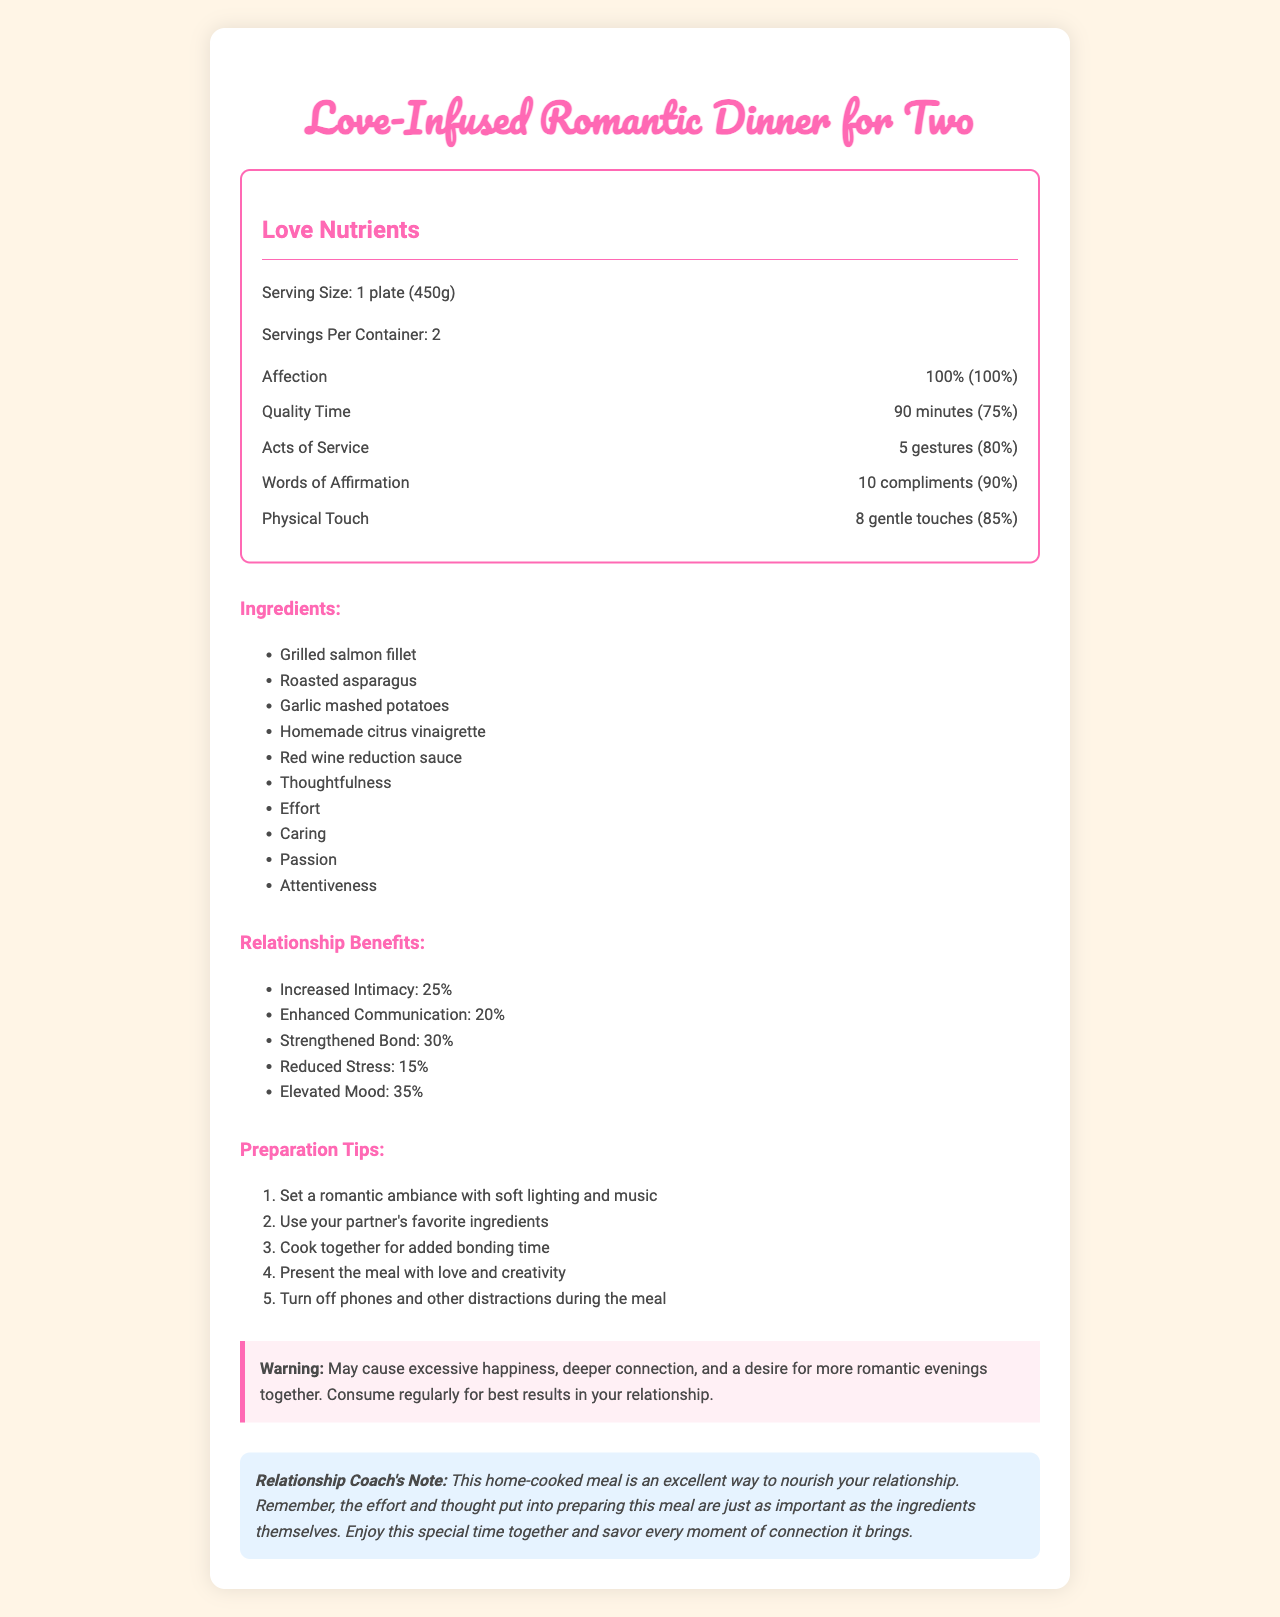what is the serving size for the meal? The document states that the serving size is "1 plate (450g)".
Answer: 1 plate (450g) how many gestures of Acts of Service are included in the meal? The "Acts of Service" nutrient lists "5 gestures" as the amount.
Answer: 5 gestures what is the daily value percentage of Words of Affirmation? The daily value percentage for "Words of Affirmation" is listed as 90% in the "Love Nutrients" section.
Answer: 90% list three ingredients used in the meal. The ingredients listed in the document include grilled salmon fillet, roasted asparagus, garlic mashed potatoes, among others.
Answer: Grilled salmon fillet, roasted asparagus, garlic mashed potatoes what is the relationship benefit with the highest percentage increase? Elevated Mood has a 35% increase, which is the highest listed.
Answer: Elevated Mood which preparation tip emphasizes reducing distractions? One of the preparation tips advises to "Turn off phones and other distractions during the meal."
Answer: Turn off phones and other distractions during the meal what is a potential side effect of consuming this meal regularly? The warning box mentions these side effects.
Answer: Excessive happiness, deeper connection, and a desire for more romantic evenings together how many servings per container are there? A. 1 B. 2 C. 3 D. 4 The document mentions that there are "2" servings per container.
Answer: B. 2 what is the amount of Quality Time in one serving? A. 60 minutes B. 75 minutes C. 90 minutes D. 120 minutes The amount of Quality Time is listed as "90 minutes" in the "Love Nutrients" section.
Answer: C. 90 minutes is there a mention of "effort" as an ingredient? Yes/No "Effort" is listed as one of the ingredients in the meal.
Answer: Yes summarize the entire document. The document uses a whimsical approach to illustrate how a romantic dinner can enhance a relationship. It includes detailed "nutrients", ingredients, relationship benefits, preparation tips, a warning, and a coach's note to underline the impact of thoughtful gestures on a partnership.
Answer: The document is a playful representation of a Nutrition Facts label for a "Love-Infused Romantic Dinner for Two." It highlights "Love Nutrients" such as Affection, Quality Time, Acts of Service, Words of Affirmation, and Physical Touch with respective amounts and daily values. The ingredients include a variety of food items and abstract elements like Thoughtfulness and Caring. It outlines relationship benefits, preparation tips, provides a warning about excessive happiness, and includes a note from a relationship coach emphasizing the importance of effort and thoughtfulness. what is the exact recipe for the garlic mashed potatoes? The document lists "garlic mashed potatoes" as an ingredient but does not provide the recipe or preparation steps.
Answer: Cannot be determined of the love nutrients listed, which one has the highest daily value percentage? The document shows that Affection has a daily value of 100%, which is the highest.
Answer: Affection explain how the document encourages partners to enhance their relationship through cooking. The document uses a mock nutrition label format to frame relationship-building activities in an enjoyable way. The inclusion of "love nutrients" and relationship benefits aligns the act of cooking and sharing a meal with nurturing and enhancing a romantic partnership.
Answer: The document encourages partners to enhance their relationship by providing a fun and engaging framework for a romantic dinner. It highlights various forms of affection and connection (like Quality Time and Acts of Service), incorporates thoughtful ingredients, suggests preparation tips that promote bonding, and emphasizes the importance of effort and creativity in the process. The relationship coach's note further underlines the sentimental value of the effort put into the meal. 